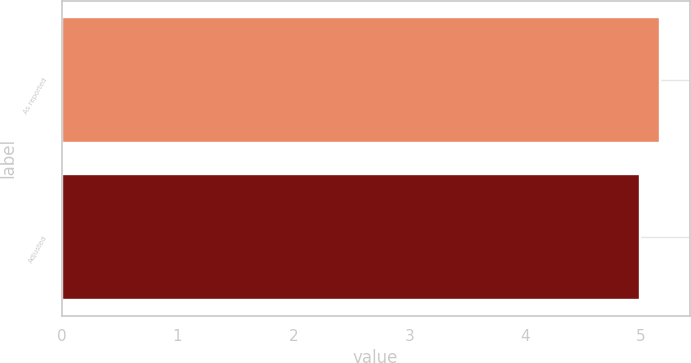Convert chart to OTSL. <chart><loc_0><loc_0><loc_500><loc_500><bar_chart><fcel>As reported<fcel>Adjusted<nl><fcel>5.16<fcel>4.99<nl></chart> 